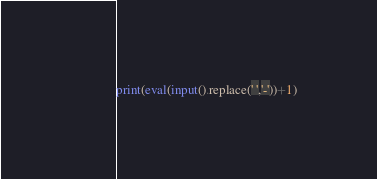<code> <loc_0><loc_0><loc_500><loc_500><_Python_>print(eval(input().replace(' ','-'))+1)</code> 